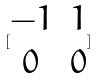Convert formula to latex. <formula><loc_0><loc_0><loc_500><loc_500>[ \begin{matrix} - 1 & 1 \\ 0 & 0 \end{matrix} ]</formula> 